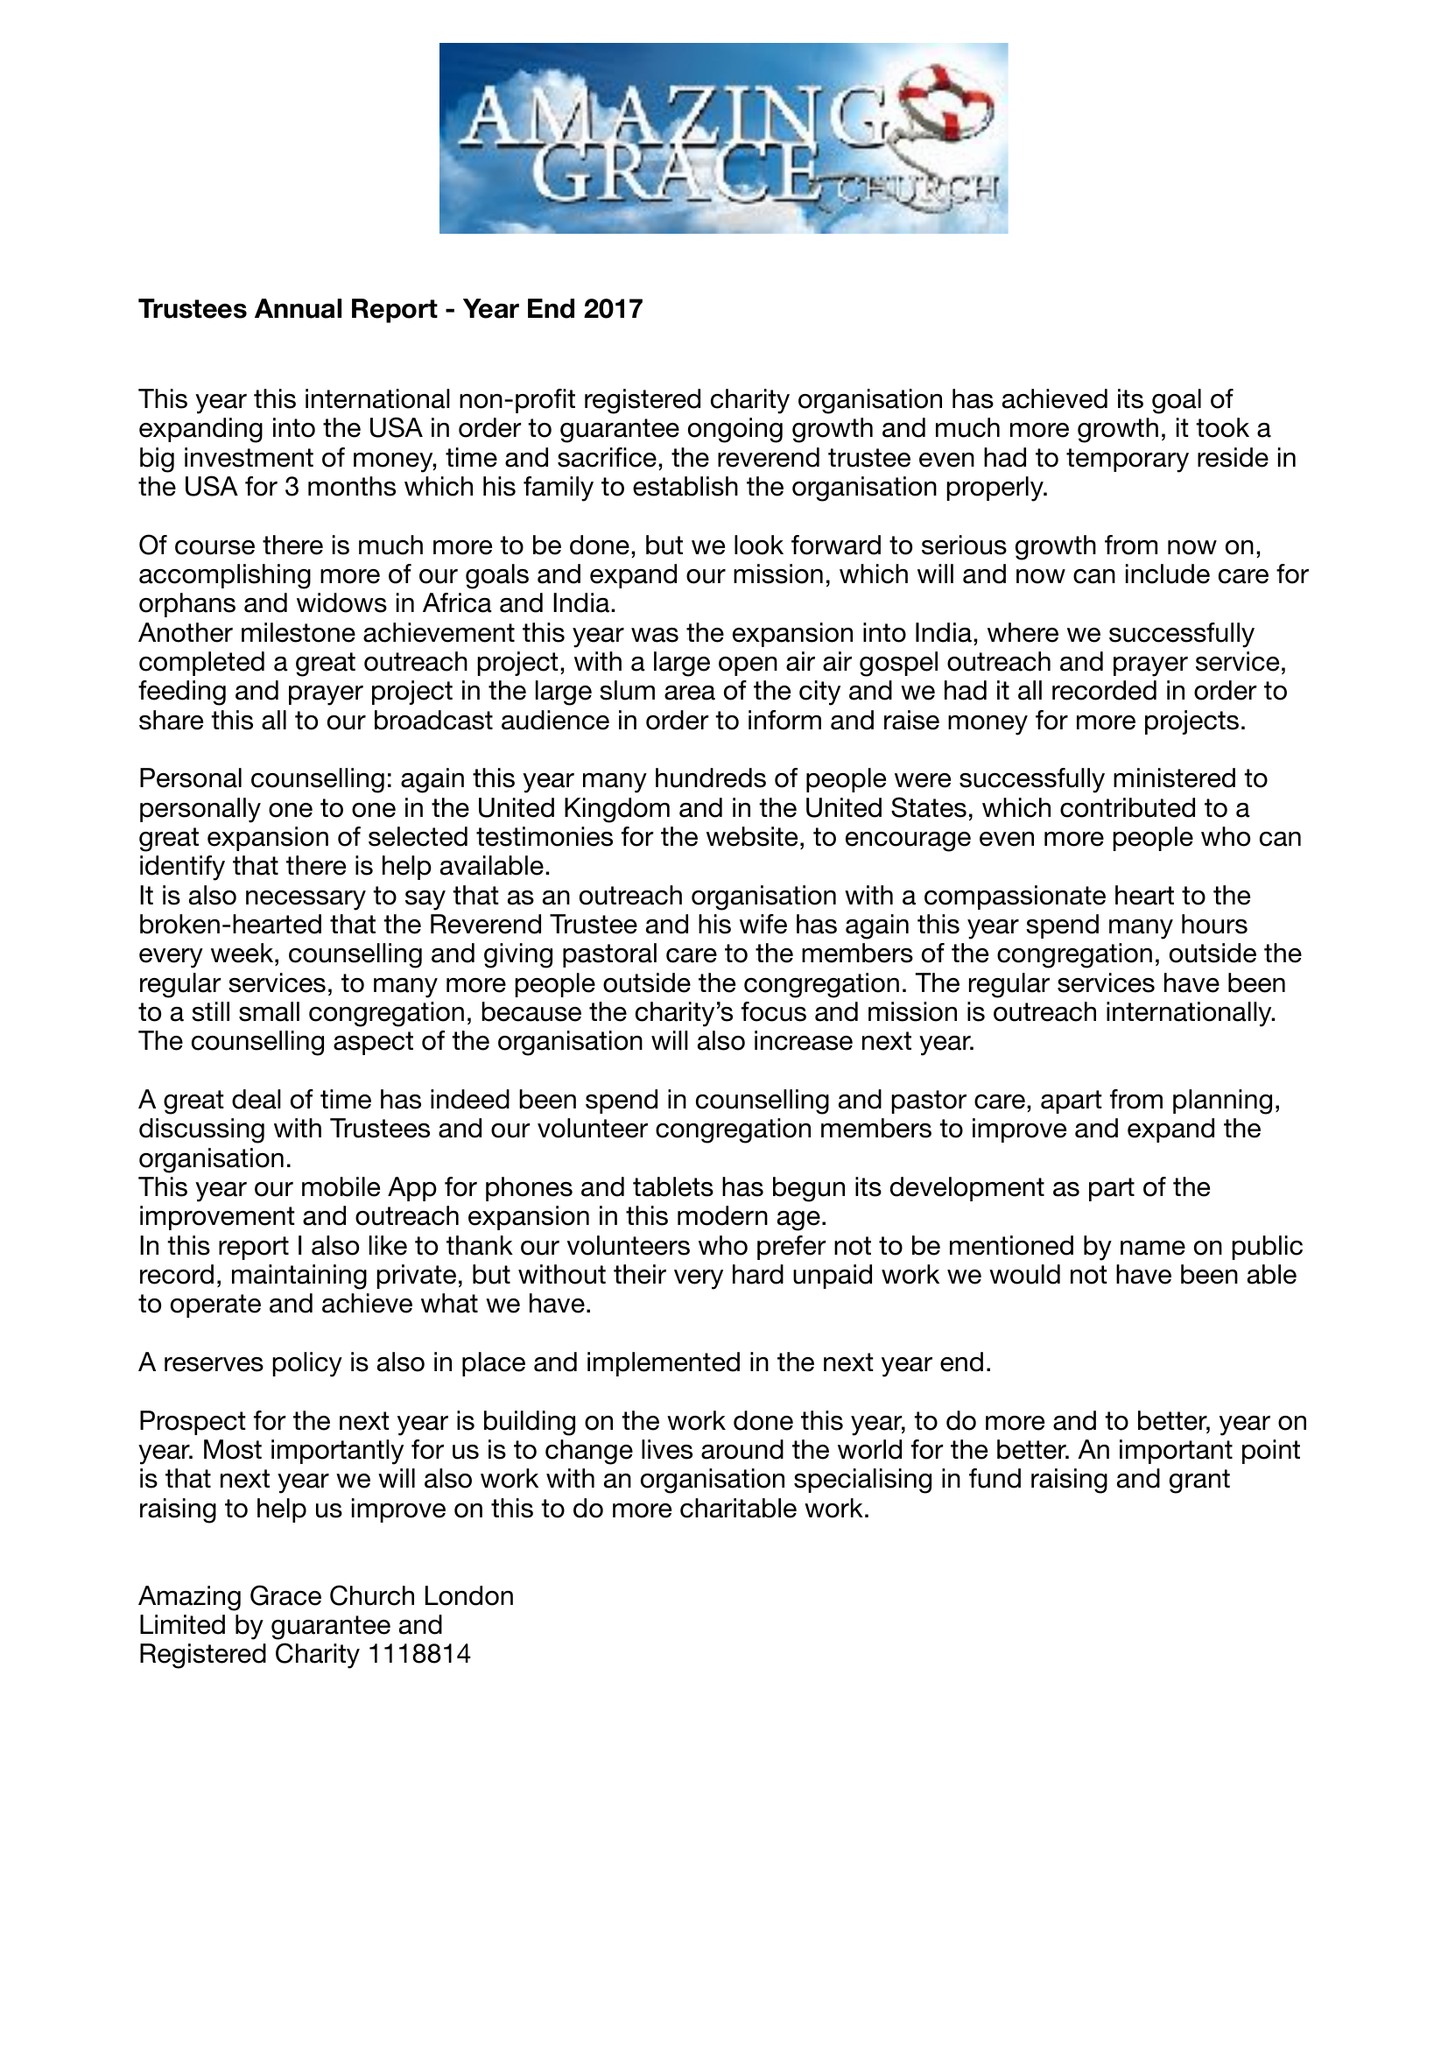What is the value for the address__street_line?
Answer the question using a single word or phrase. 27 OLD GLOUCESTER STREET 